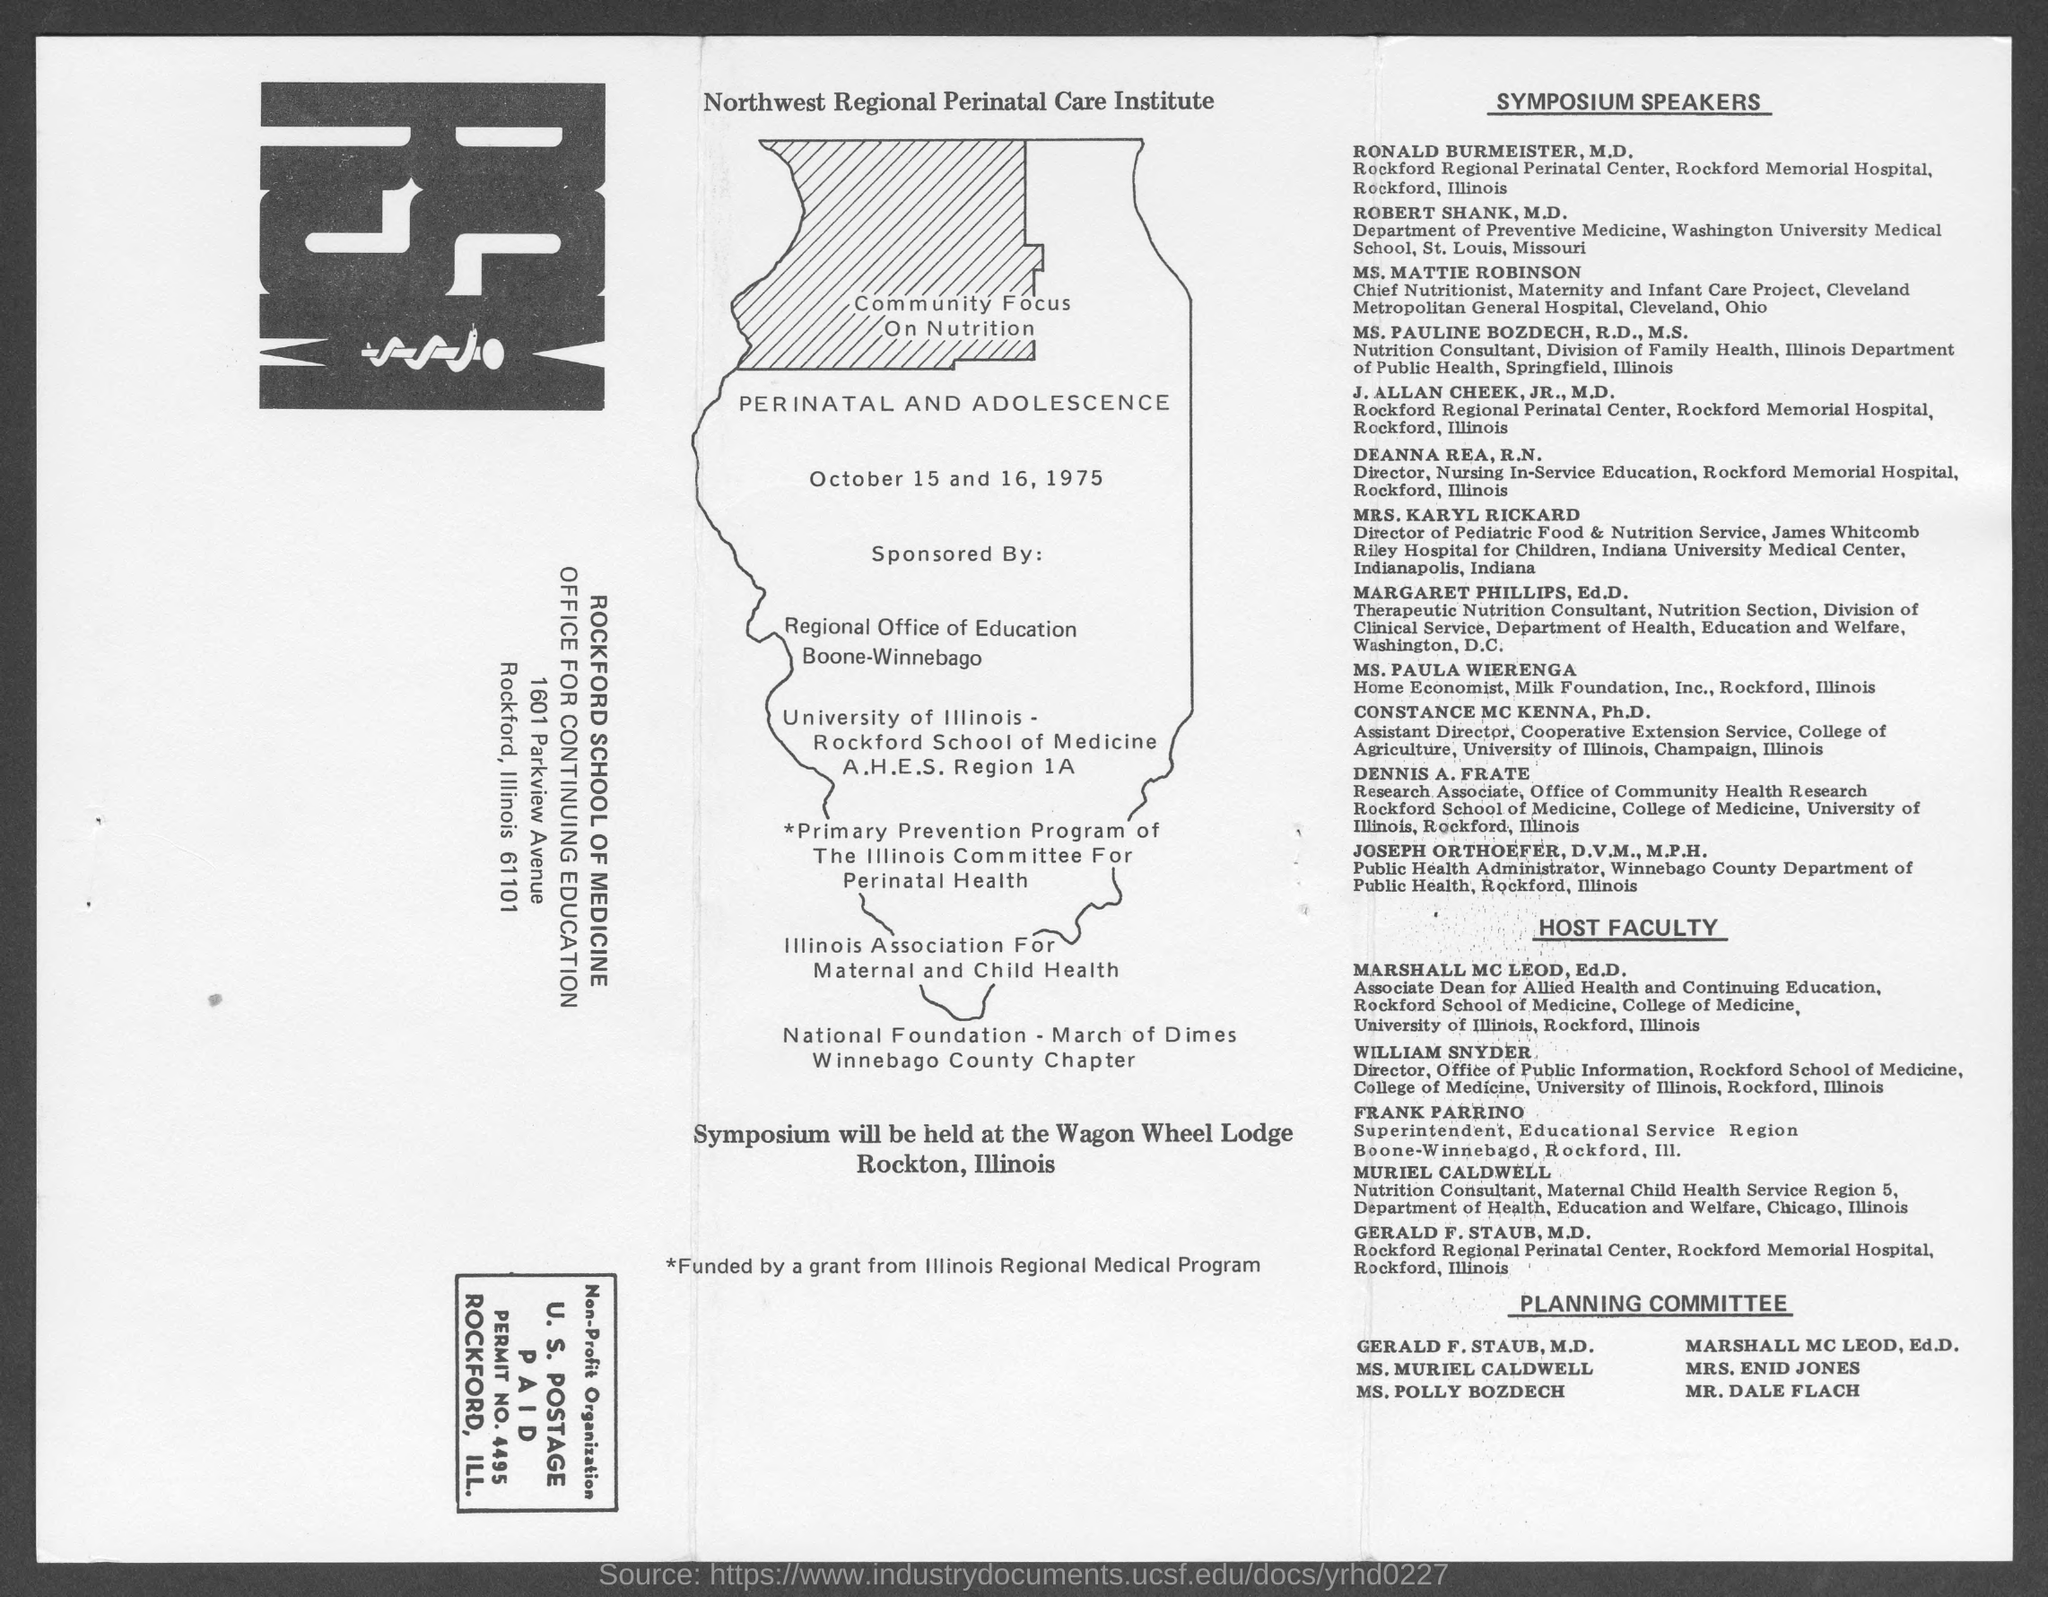Draw attention to some important aspects in this diagram. The Community Focus on Nutrition program took place on October 15 and 16, 1975. Marshall Mc Leod is the Associate Dean for Allied Health and Continuing Education. William Snyder is the Director of the Office of Public Information. 